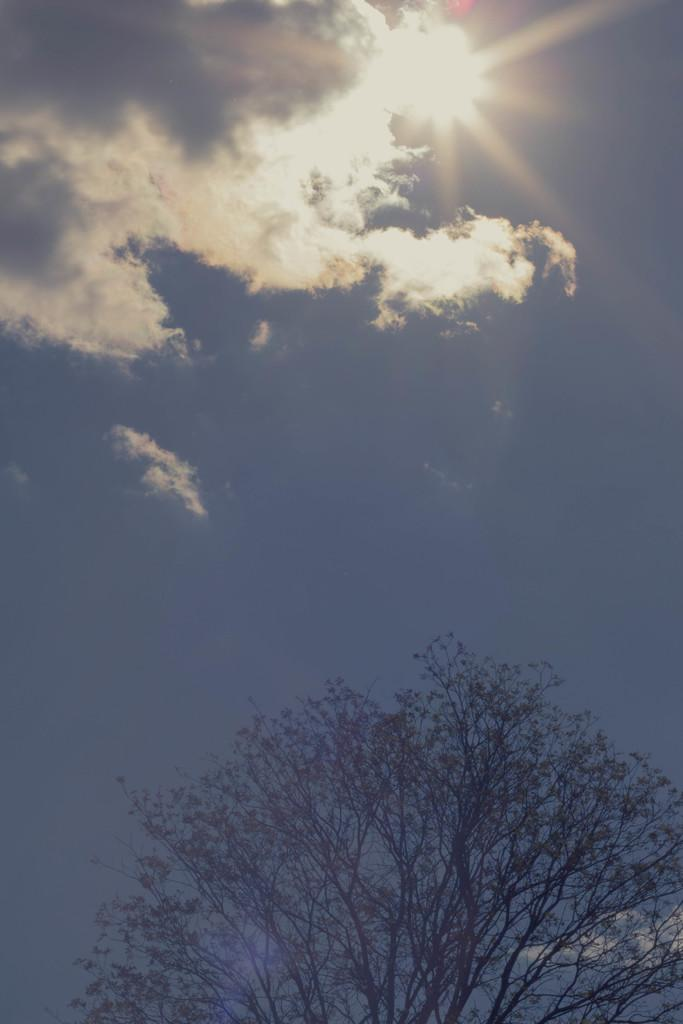What type of plant can be seen in the image? There is a tree in the image. What part of the natural environment is visible in the image? The sky is visible in the image. Can the sun be seen in the image? Yes, the sun is observable in the sky. What type of wound can be seen on the tree in the image? There is no wound visible on the tree in the image. What type of linen is draped over the branches of the tree in the image? There is no linen present in the image. Is there a ghost visible in the image? There is no ghost present in the image. 